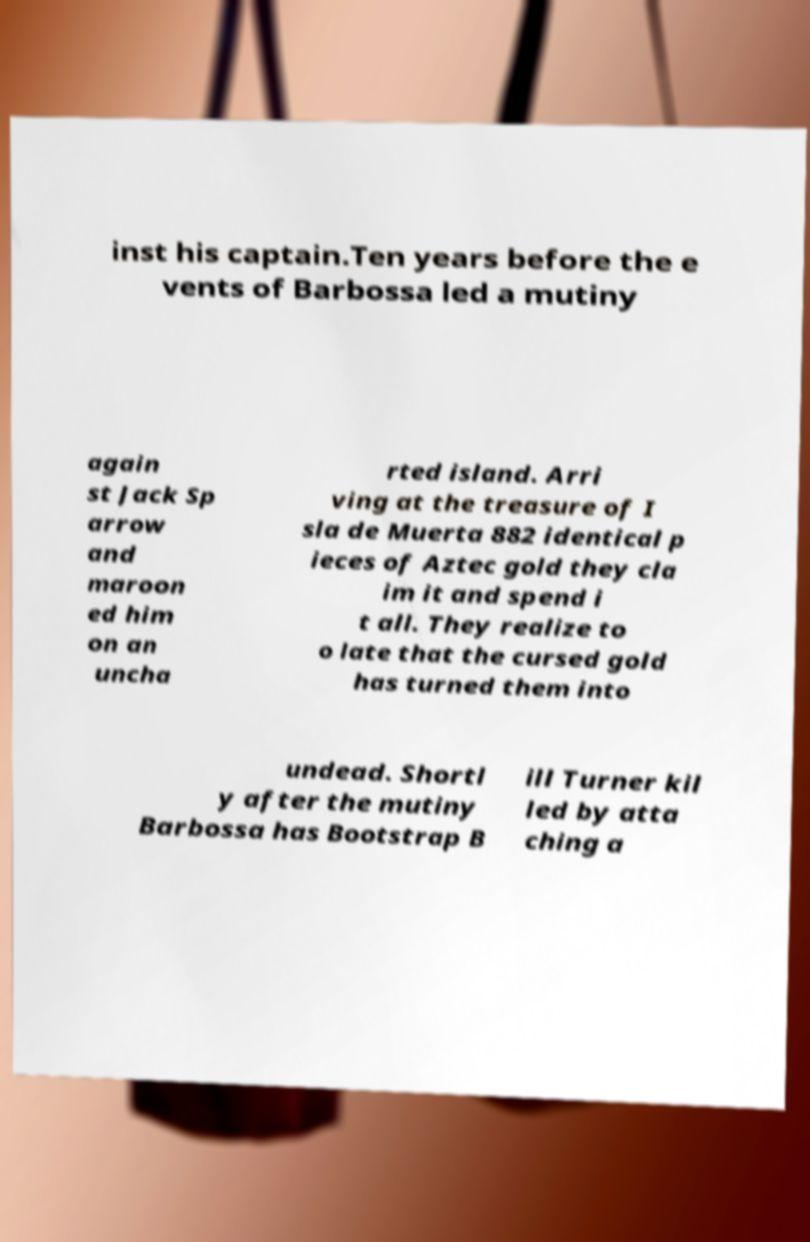There's text embedded in this image that I need extracted. Can you transcribe it verbatim? inst his captain.Ten years before the e vents of Barbossa led a mutiny again st Jack Sp arrow and maroon ed him on an uncha rted island. Arri ving at the treasure of I sla de Muerta 882 identical p ieces of Aztec gold they cla im it and spend i t all. They realize to o late that the cursed gold has turned them into undead. Shortl y after the mutiny Barbossa has Bootstrap B ill Turner kil led by atta ching a 